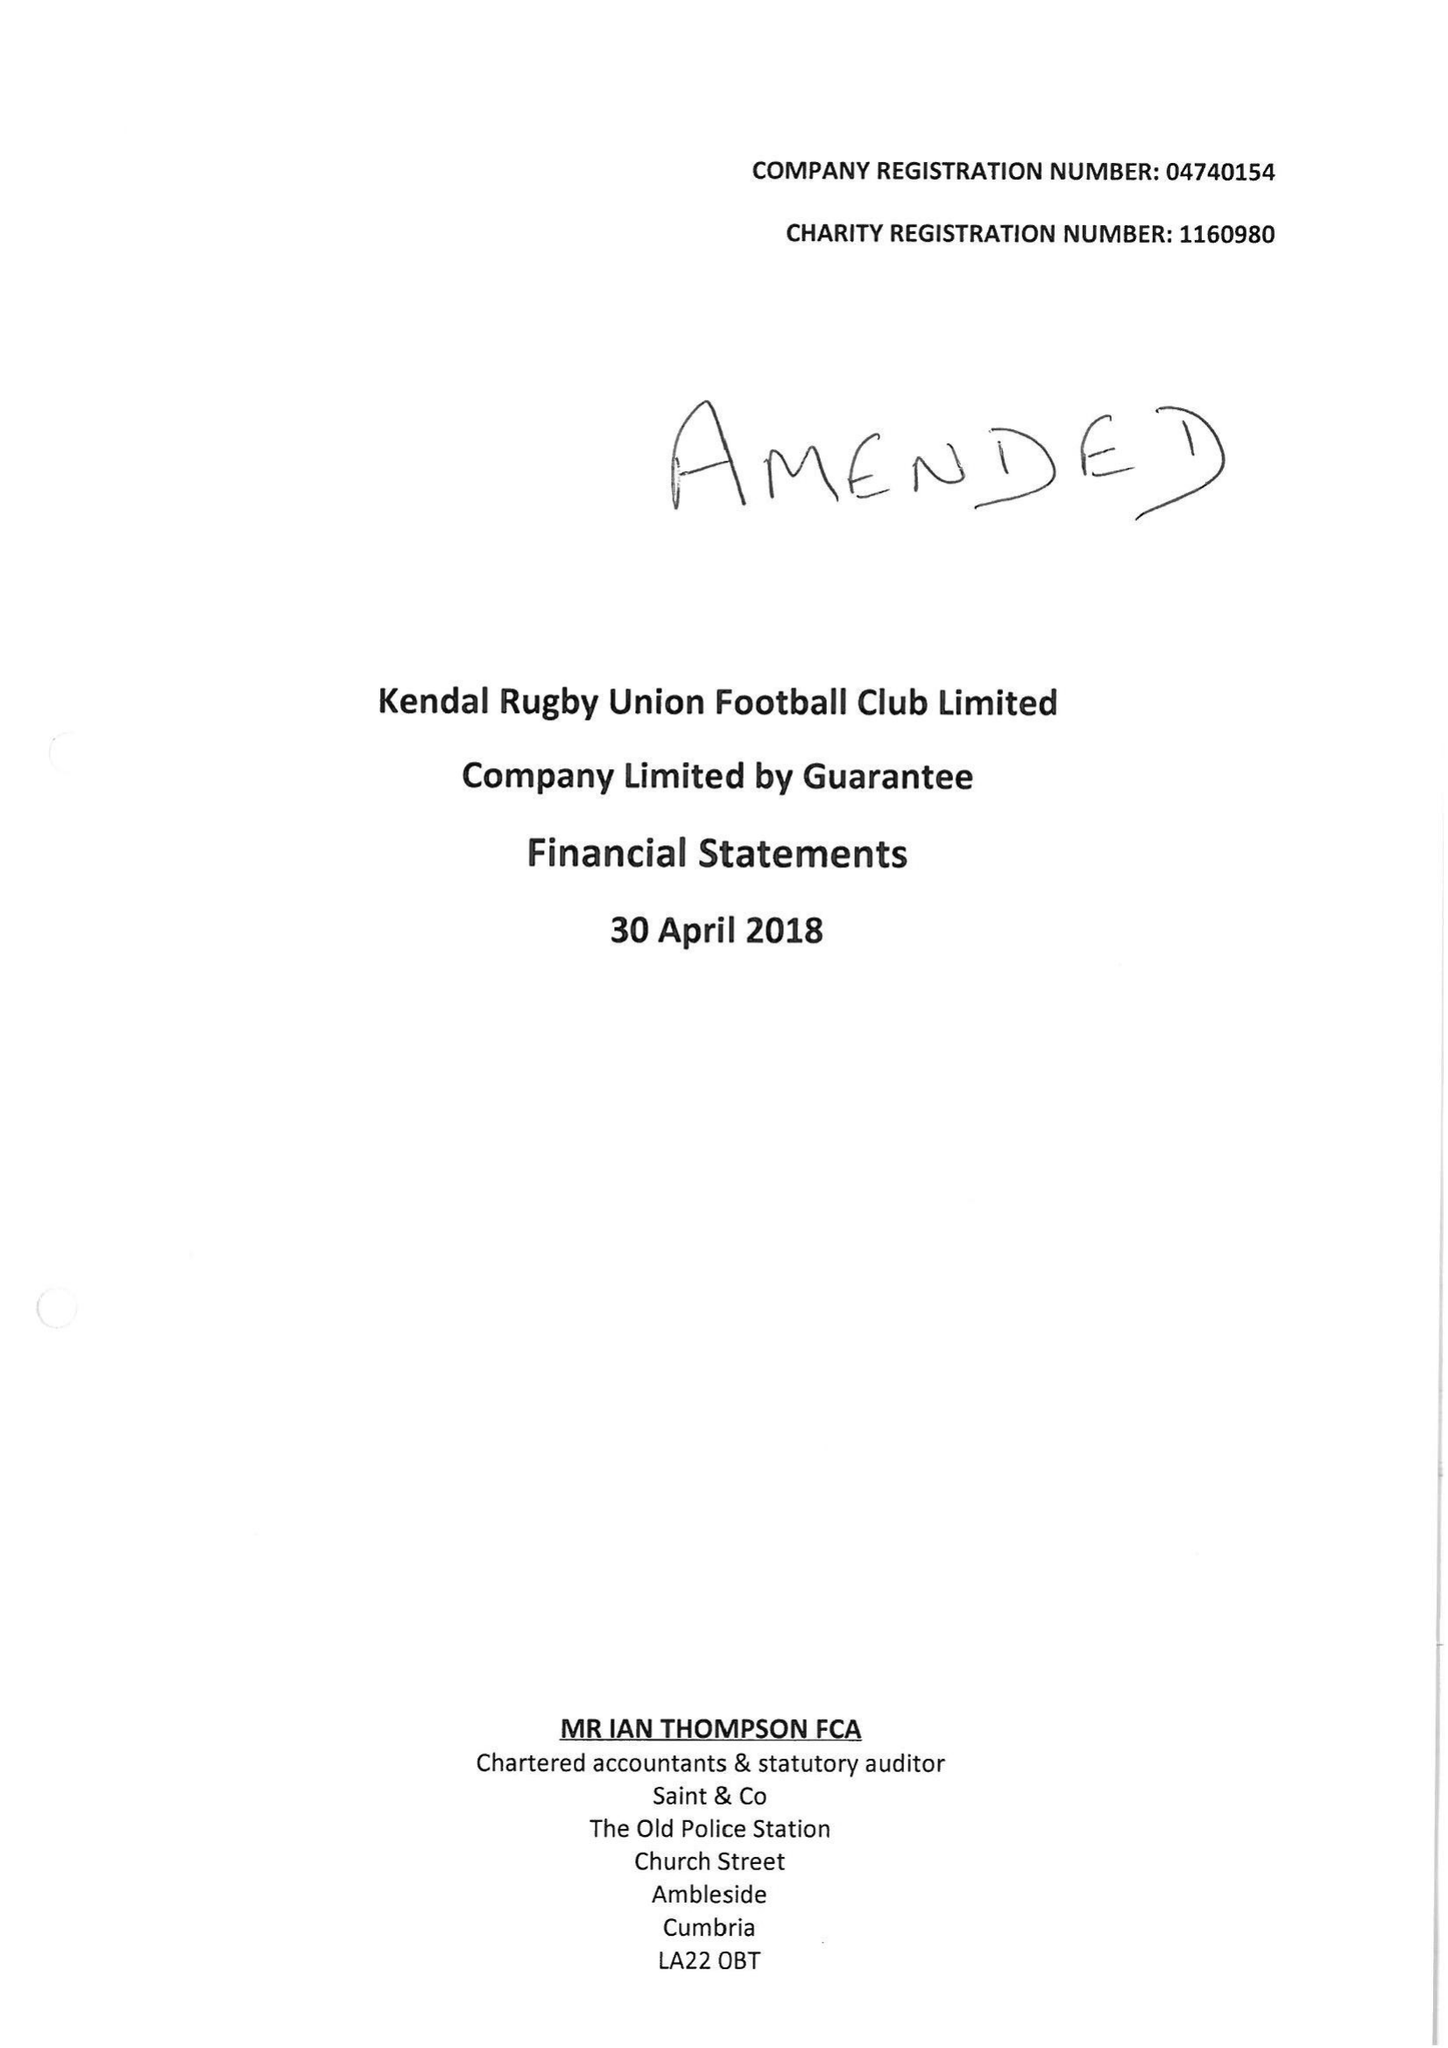What is the value for the charity_name?
Answer the question using a single word or phrase. Kendal Rugby Union Football Club Ltd. 